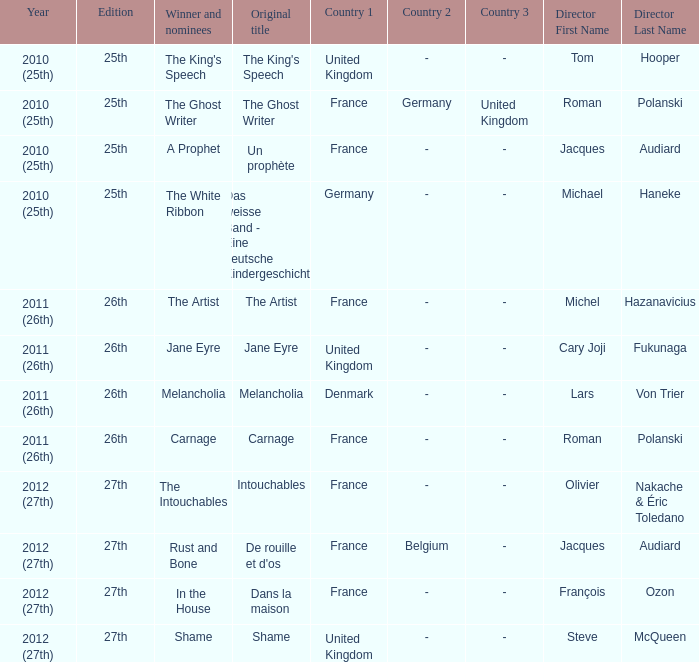What was the original title of the king's speech? The King's Speech. Could you parse the entire table? {'header': ['Year', 'Edition', 'Winner and nominees', 'Original title', 'Country 1', 'Country 2', 'Country 3', 'Director First Name', 'Director Last Name'], 'rows': [['2010 (25th)', '25th', "The King's Speech", "The King's Speech", 'United Kingdom', '-', '-', 'Tom', 'Hooper'], ['2010 (25th)', '25th', 'The Ghost Writer', 'The Ghost Writer', 'France', 'Germany', 'United Kingdom', 'Roman', 'Polanski'], ['2010 (25th)', '25th', 'A Prophet', 'Un prophète', 'France', '-', '-', 'Jacques', 'Audiard'], ['2010 (25th)', '25th', 'The White Ribbon', 'Das weisse Band - Eine deutsche Kindergeschichte', 'Germany', '-', '-', 'Michael', 'Haneke'], ['2011 (26th)', '26th', 'The Artist', 'The Artist', 'France', '-', '-', 'Michel', 'Hazanavicius'], ['2011 (26th)', '26th', 'Jane Eyre', 'Jane Eyre', 'United Kingdom', '-', '-', 'Cary Joji', 'Fukunaga'], ['2011 (26th)', '26th', 'Melancholia', 'Melancholia', 'Denmark', '-', '-', 'Lars', 'Von Trier'], ['2011 (26th)', '26th', 'Carnage', 'Carnage', 'France', '-', '-', 'Roman', 'Polanski'], ['2012 (27th)', '27th', 'The Intouchables', 'Intouchables', 'France', '-', '-', 'Olivier', 'Nakache & Éric Toledano'], ['2012 (27th)', '27th', 'Rust and Bone', "De rouille et d'os", 'France', 'Belgium', '-', 'Jacques', 'Audiard'], ['2012 (27th)', '27th', 'In the House', 'Dans la maison', 'France', '-', '-', 'François', 'Ozon'], ['2012 (27th)', '27th', 'Shame', 'Shame', 'United Kingdom', '-', '-', 'Steve', 'McQueen']]} 